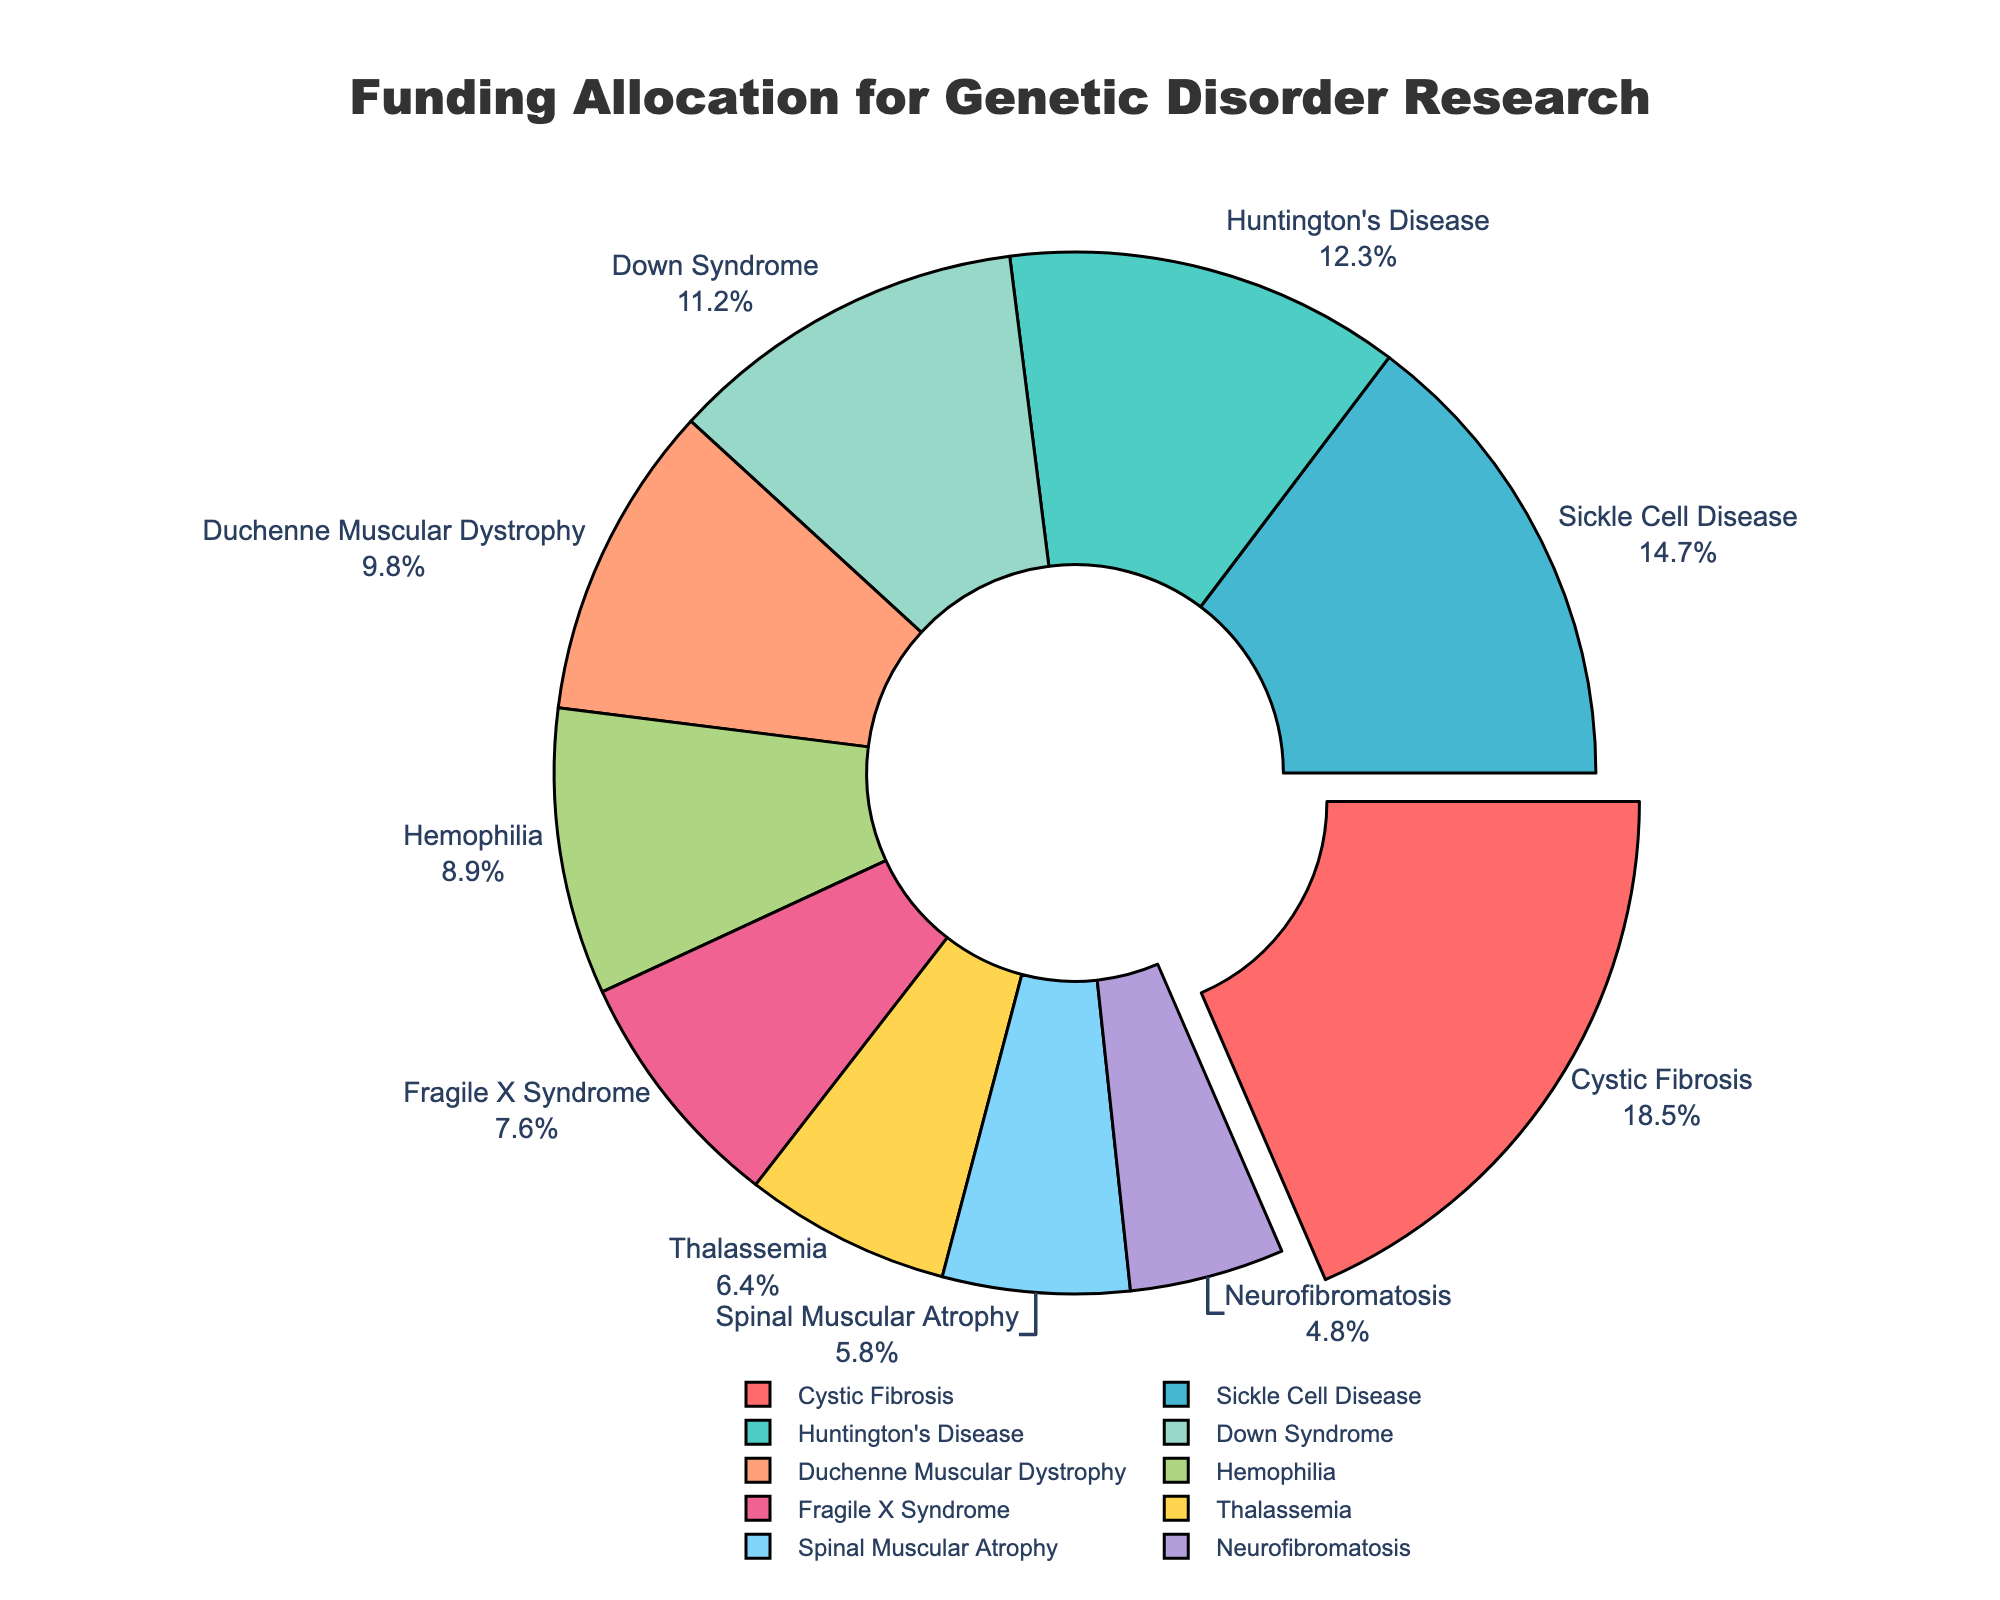What percentage of funding goes to cystic fibrosis research? Cystic fibrosis research is assigned a funding percentage of 18.5%. This information is directly visible on the chart where cystic fibrosis is labeled.
Answer: 18.5% Which genetic disorder receives the least amount of funding? By inspecting the pie chart, the section labeled Neurofibromatosis has the smallest visual slice and is marked with a percentage of 4.8%, indicating it receives the least funding.
Answer: Neurofibromatosis How does the funding for Huntington's disease compare to that for Thalassemia? The pie chart shows Huntington's Disease has 12.3% funding and Thalassemia has 6.4% funding. Comparing these values, Huntington's Disease receives more funding than Thalassemia.
Answer: Huntington's Disease receives more funding than Thalassemia What's the combined funding percentage for Duchenne muscular dystrophy and Down syndrome? Duchenne muscular dystrophy has 9.8% funding and Down syndrome has 11.2% funding. Adding these two percentages together, the combined funding is 9.8% + 11.2% = 21%.
Answer: 21% Is the funding percentage for hemophilia more than or less than that for sickle cell disease? The pie chart indicates that sickle cell disease has 14.7% funding while hemophilia has 8.9% funding. Thus, the funding for hemophilia is less than that for sickle cell disease.
Answer: Less than What's the total funding percentage for genetic disorders receiving less than 10% funding each? The disorders receiving less than 10% funding are Duchenne muscular dystrophy (9.8%), Fragile X Syndrome (7.6%), Hemophilia (8.9%), Thalassemia (6.4%), Spinal Muscular Atrophy (5.8%), and Neurofibromatosis (4.8%). Summing these percentages: 9.8% + 7.6% + 8.9% + 6.4% + 5.8% + 4.8% = 43.3%.
Answer: 43.3% Which disorder has the largest slice in the pie chart, and what is unique about its depiction? Cystic fibrosis has the largest slice at 18.5%. Its depiction is unique because the slice is slightly pulled out from the pie, highlighting it as having the highest funding percentage.
Answer: Cystic fibrosis; largest slice and pulled out What is the average funding percentage across all categories? There are 10 categories. Adding all percentages: 18.5% + 12.3% + 14.7% + 9.8% + 11.2% + 7.6% + 8.9% + 6.4% + 5.8% + 4.8% = 100%. The average funding percentage is 100% / 10 = 10%.
Answer: 10% 